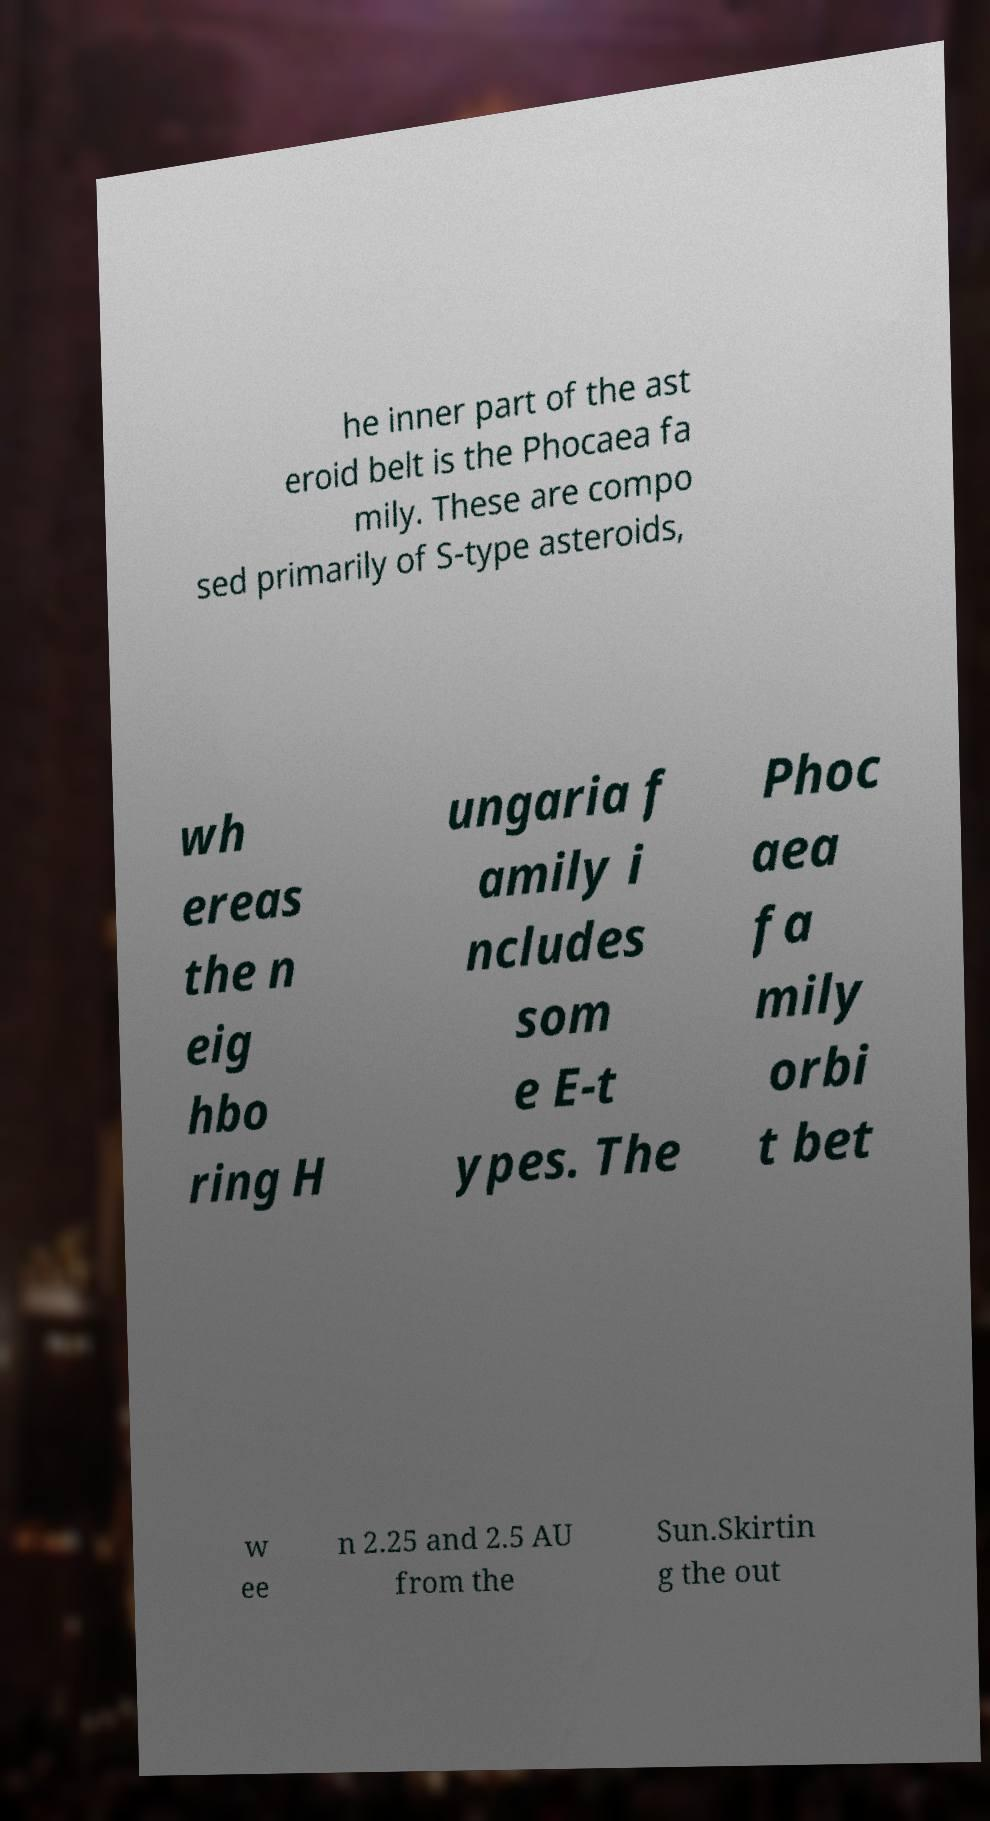I need the written content from this picture converted into text. Can you do that? he inner part of the ast eroid belt is the Phocaea fa mily. These are compo sed primarily of S-type asteroids, wh ereas the n eig hbo ring H ungaria f amily i ncludes som e E-t ypes. The Phoc aea fa mily orbi t bet w ee n 2.25 and 2.5 AU from the Sun.Skirtin g the out 